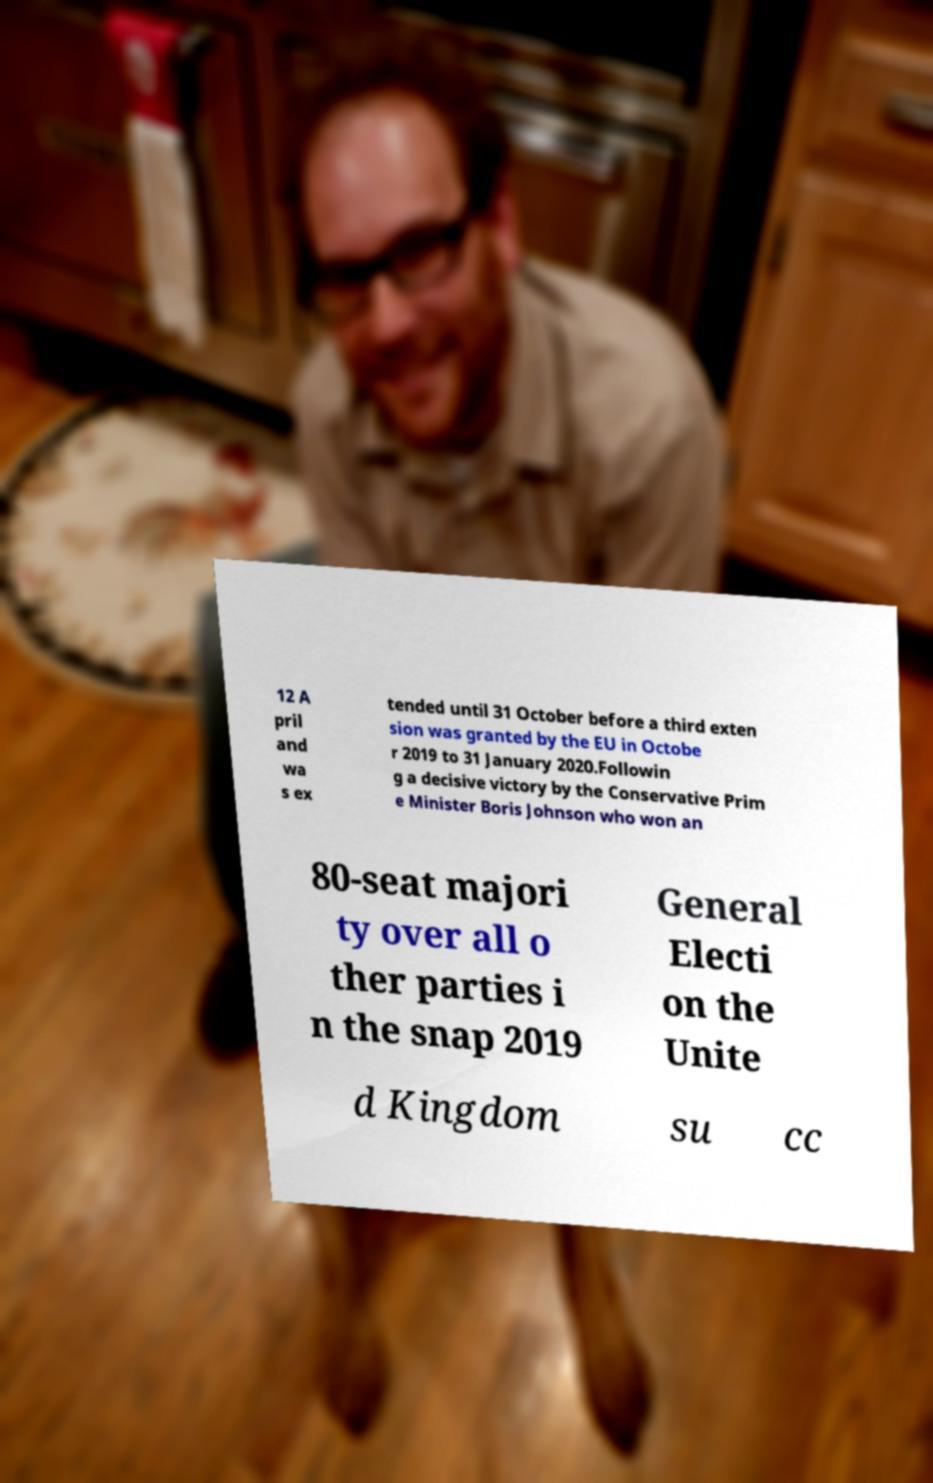Can you accurately transcribe the text from the provided image for me? 12 A pril and wa s ex tended until 31 October before a third exten sion was granted by the EU in Octobe r 2019 to 31 January 2020.Followin g a decisive victory by the Conservative Prim e Minister Boris Johnson who won an 80-seat majori ty over all o ther parties i n the snap 2019 General Electi on the Unite d Kingdom su cc 